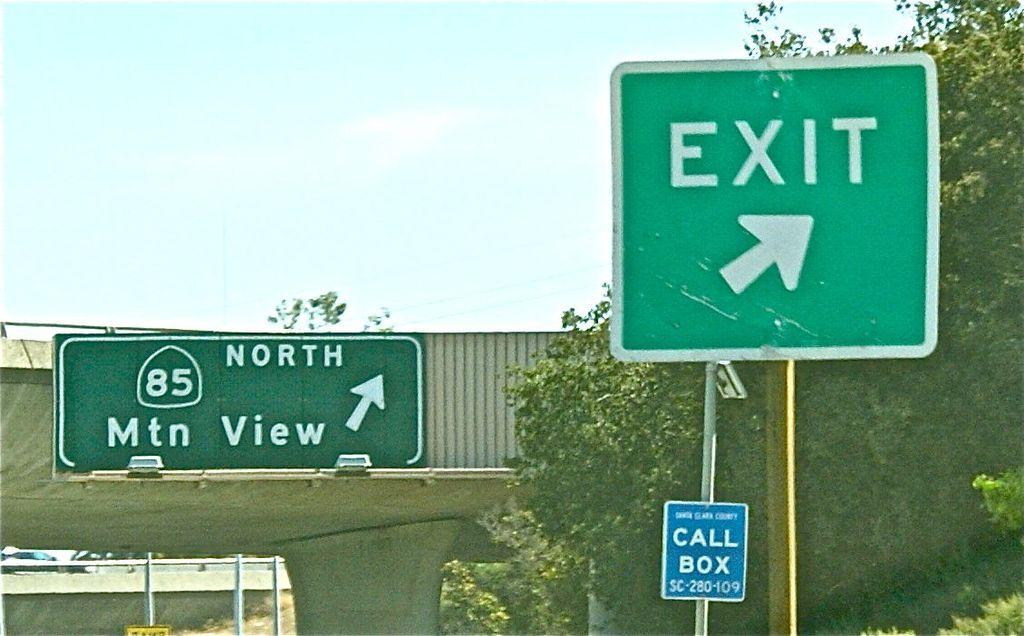<image>
Present a compact description of the photo's key features. an exit sign that has an arrow on it 